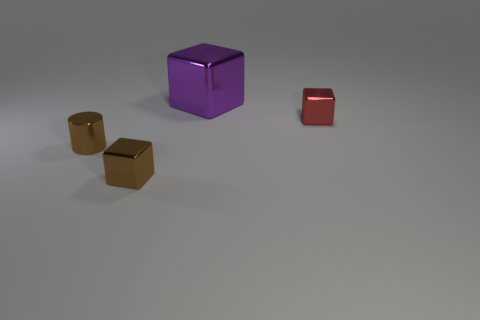Subtract all small shiny blocks. How many blocks are left? 1 Add 2 large purple metal things. How many objects exist? 6 Subtract 3 cubes. How many cubes are left? 0 Subtract all purple cubes. How many cubes are left? 2 Subtract all blocks. How many objects are left? 1 Subtract all purple cylinders. Subtract all cyan blocks. How many cylinders are left? 1 Subtract all green balls. How many purple cubes are left? 1 Subtract all matte blocks. Subtract all big purple things. How many objects are left? 3 Add 4 big cubes. How many big cubes are left? 5 Add 3 metallic cubes. How many metallic cubes exist? 6 